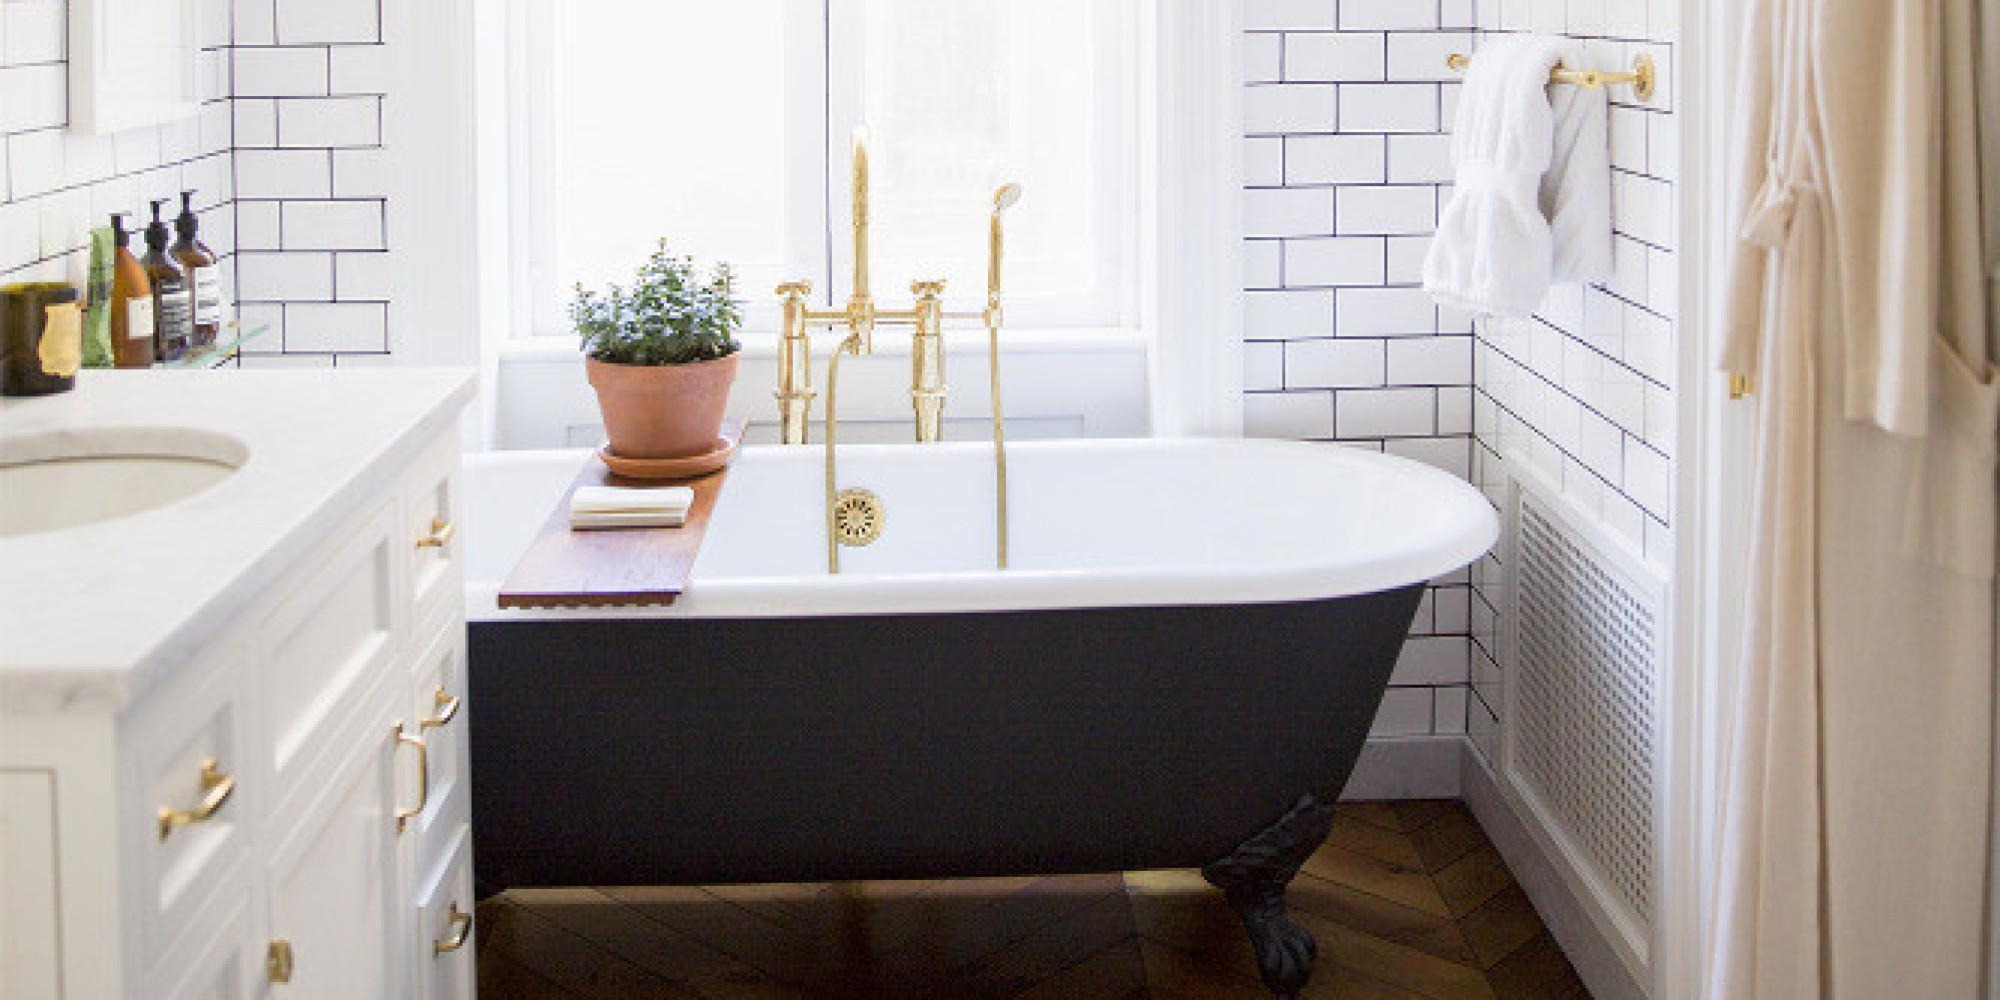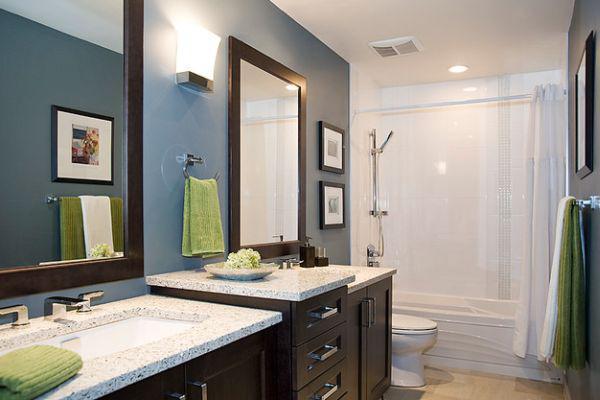The first image is the image on the left, the second image is the image on the right. For the images shown, is this caption "At least one bathroom has a stepstool." true? Answer yes or no. No. The first image is the image on the left, the second image is the image on the right. For the images displayed, is the sentence "An image features a room with solid-white walls, and a shower curtain featuring a turquoise lower half around an all-white tub." factually correct? Answer yes or no. No. 